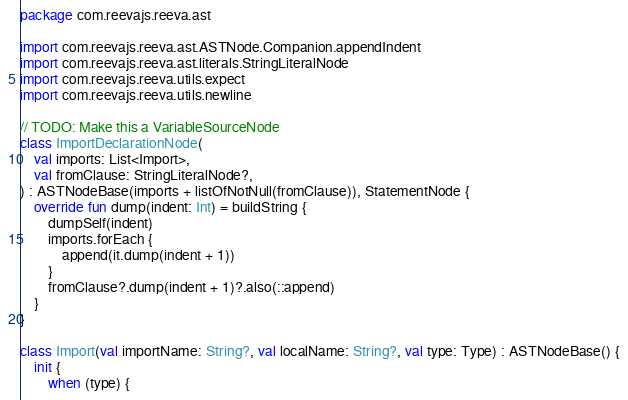<code> <loc_0><loc_0><loc_500><loc_500><_Kotlin_>package com.reevajs.reeva.ast

import com.reevajs.reeva.ast.ASTNode.Companion.appendIndent
import com.reevajs.reeva.ast.literals.StringLiteralNode
import com.reevajs.reeva.utils.expect
import com.reevajs.reeva.utils.newline

// TODO: Make this a VariableSourceNode
class ImportDeclarationNode(
    val imports: List<Import>,
    val fromClause: StringLiteralNode?,
) : ASTNodeBase(imports + listOfNotNull(fromClause)), StatementNode {
    override fun dump(indent: Int) = buildString {
        dumpSelf(indent)
        imports.forEach {
            append(it.dump(indent + 1))
        }
        fromClause?.dump(indent + 1)?.also(::append)
    }
}

class Import(val importName: String?, val localName: String?, val type: Type) : ASTNodeBase() {
    init {
        when (type) {</code> 